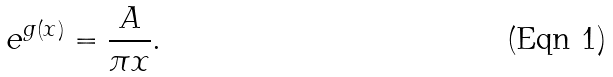Convert formula to latex. <formula><loc_0><loc_0><loc_500><loc_500>e ^ { g ( x ) } = \frac { A } { \pi x } .</formula> 